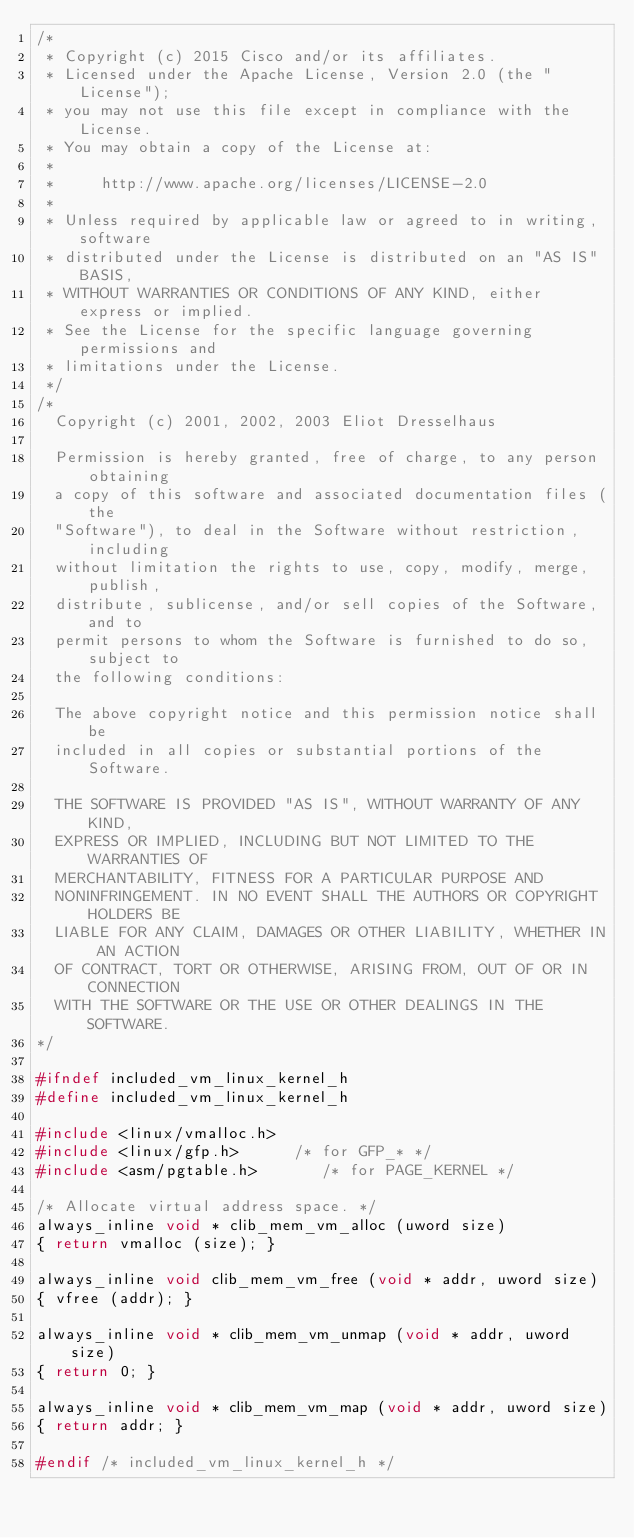<code> <loc_0><loc_0><loc_500><loc_500><_C_>/*
 * Copyright (c) 2015 Cisco and/or its affiliates.
 * Licensed under the Apache License, Version 2.0 (the "License");
 * you may not use this file except in compliance with the License.
 * You may obtain a copy of the License at:
 *
 *     http://www.apache.org/licenses/LICENSE-2.0
 *
 * Unless required by applicable law or agreed to in writing, software
 * distributed under the License is distributed on an "AS IS" BASIS,
 * WITHOUT WARRANTIES OR CONDITIONS OF ANY KIND, either express or implied.
 * See the License for the specific language governing permissions and
 * limitations under the License.
 */
/*
  Copyright (c) 2001, 2002, 2003 Eliot Dresselhaus

  Permission is hereby granted, free of charge, to any person obtaining
  a copy of this software and associated documentation files (the
  "Software"), to deal in the Software without restriction, including
  without limitation the rights to use, copy, modify, merge, publish,
  distribute, sublicense, and/or sell copies of the Software, and to
  permit persons to whom the Software is furnished to do so, subject to
  the following conditions:

  The above copyright notice and this permission notice shall be
  included in all copies or substantial portions of the Software.

  THE SOFTWARE IS PROVIDED "AS IS", WITHOUT WARRANTY OF ANY KIND,
  EXPRESS OR IMPLIED, INCLUDING BUT NOT LIMITED TO THE WARRANTIES OF
  MERCHANTABILITY, FITNESS FOR A PARTICULAR PURPOSE AND
  NONINFRINGEMENT. IN NO EVENT SHALL THE AUTHORS OR COPYRIGHT HOLDERS BE
  LIABLE FOR ANY CLAIM, DAMAGES OR OTHER LIABILITY, WHETHER IN AN ACTION
  OF CONTRACT, TORT OR OTHERWISE, ARISING FROM, OUT OF OR IN CONNECTION
  WITH THE SOFTWARE OR THE USE OR OTHER DEALINGS IN THE SOFTWARE.
*/

#ifndef included_vm_linux_kernel_h
#define included_vm_linux_kernel_h

#include <linux/vmalloc.h>
#include <linux/gfp.h>		/* for GFP_* */
#include <asm/pgtable.h>       /* for PAGE_KERNEL */

/* Allocate virtual address space. */
always_inline void * clib_mem_vm_alloc (uword size)
{ return vmalloc (size); }

always_inline void clib_mem_vm_free (void * addr, uword size)
{ vfree (addr); }

always_inline void * clib_mem_vm_unmap (void * addr, uword size)
{ return 0; }

always_inline void * clib_mem_vm_map (void * addr, uword size)
{ return addr; }

#endif /* included_vm_linux_kernel_h */
</code> 